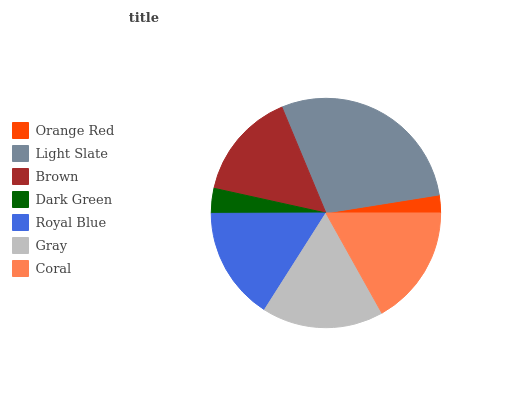Is Orange Red the minimum?
Answer yes or no. Yes. Is Light Slate the maximum?
Answer yes or no. Yes. Is Brown the minimum?
Answer yes or no. No. Is Brown the maximum?
Answer yes or no. No. Is Light Slate greater than Brown?
Answer yes or no. Yes. Is Brown less than Light Slate?
Answer yes or no. Yes. Is Brown greater than Light Slate?
Answer yes or no. No. Is Light Slate less than Brown?
Answer yes or no. No. Is Royal Blue the high median?
Answer yes or no. Yes. Is Royal Blue the low median?
Answer yes or no. Yes. Is Orange Red the high median?
Answer yes or no. No. Is Gray the low median?
Answer yes or no. No. 